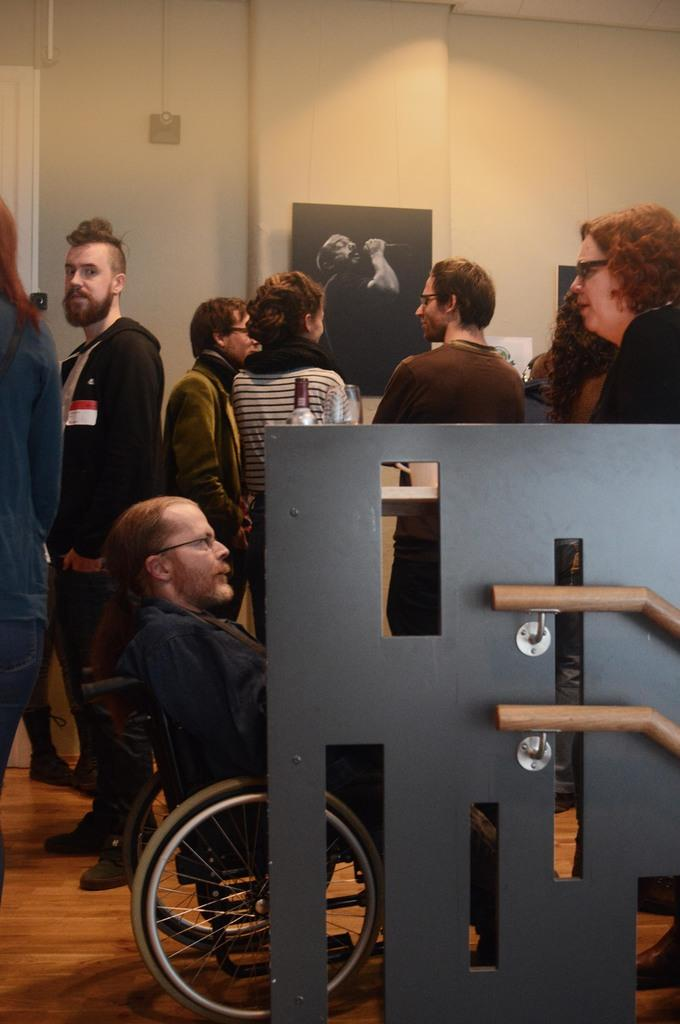How many people are in the image? There is a group of people standing in the image. Can you describe the person in the wheelchair? One person is sitting in a wheelchair. What can be seen in the background of the image? There is a photo frame and a wall in the background of the image. What type of suit is the person in the wheelchair wearing? There is no information about the person's clothing in the image, so we cannot determine if they are wearing a suit. What is the rate of the wheelchair's speed in the image? The wheelchair is not in motion in the image, so we cannot determine its speed or rate. 